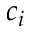Convert formula to latex. <formula><loc_0><loc_0><loc_500><loc_500>c _ { i }</formula> 